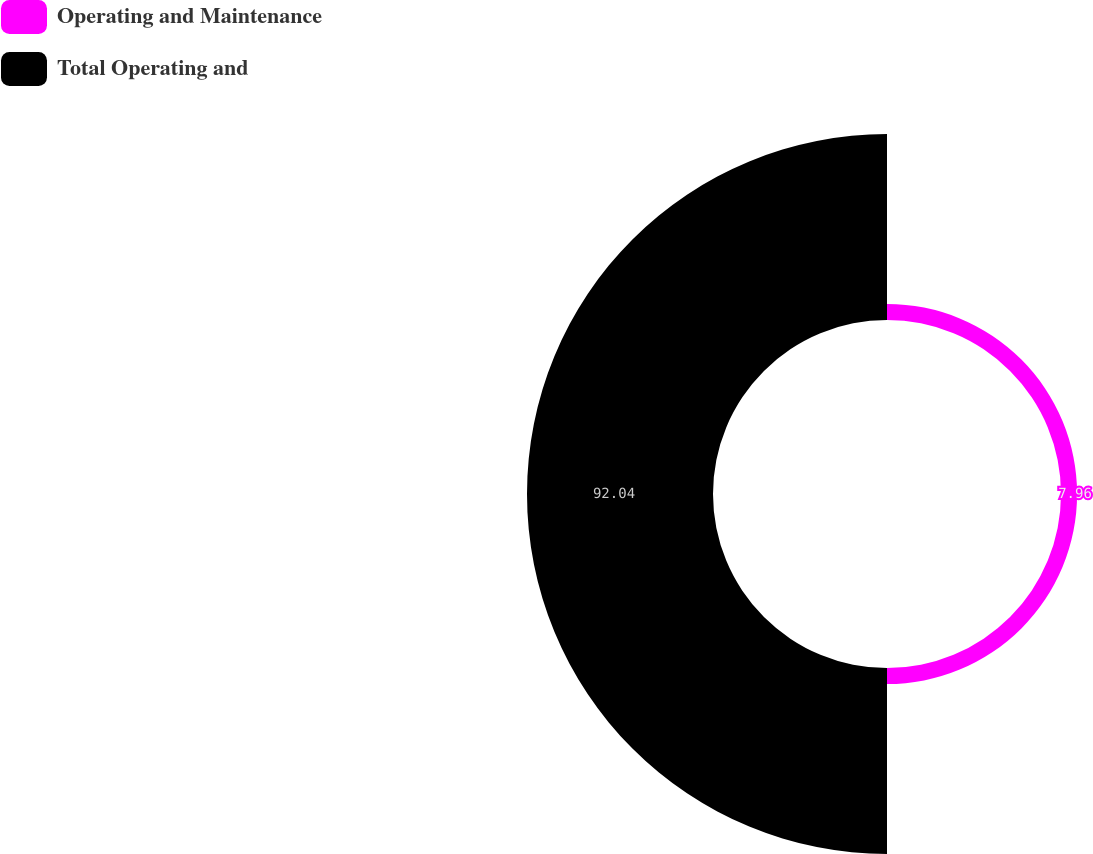<chart> <loc_0><loc_0><loc_500><loc_500><pie_chart><fcel>Operating and Maintenance<fcel>Total Operating and<nl><fcel>7.96%<fcel>92.04%<nl></chart> 